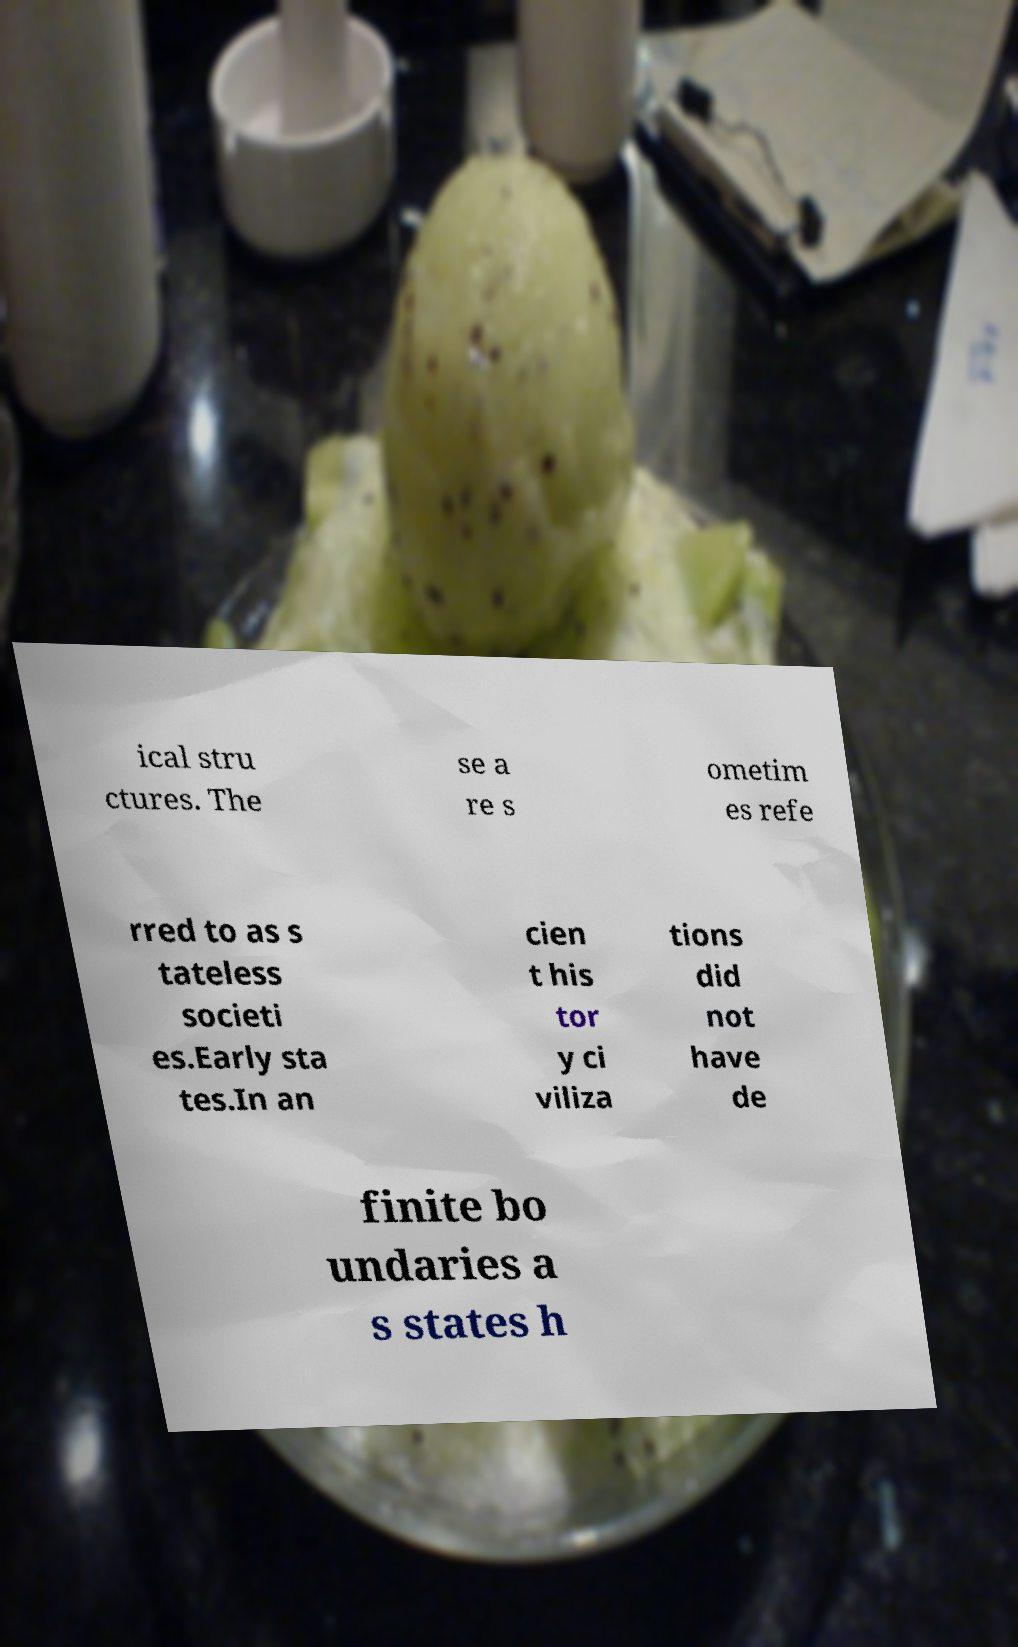Could you assist in decoding the text presented in this image and type it out clearly? ical stru ctures. The se a re s ometim es refe rred to as s tateless societi es.Early sta tes.In an cien t his tor y ci viliza tions did not have de finite bo undaries a s states h 